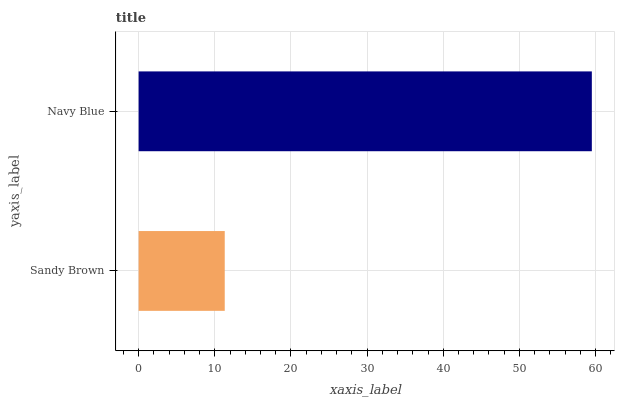Is Sandy Brown the minimum?
Answer yes or no. Yes. Is Navy Blue the maximum?
Answer yes or no. Yes. Is Navy Blue the minimum?
Answer yes or no. No. Is Navy Blue greater than Sandy Brown?
Answer yes or no. Yes. Is Sandy Brown less than Navy Blue?
Answer yes or no. Yes. Is Sandy Brown greater than Navy Blue?
Answer yes or no. No. Is Navy Blue less than Sandy Brown?
Answer yes or no. No. Is Navy Blue the high median?
Answer yes or no. Yes. Is Sandy Brown the low median?
Answer yes or no. Yes. Is Sandy Brown the high median?
Answer yes or no. No. Is Navy Blue the low median?
Answer yes or no. No. 